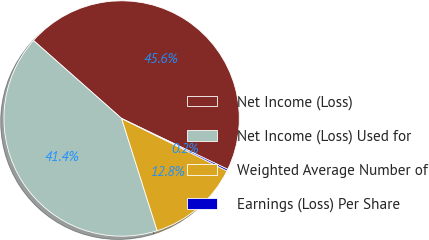<chart> <loc_0><loc_0><loc_500><loc_500><pie_chart><fcel>Net Income (Loss)<fcel>Net Income (Loss) Used for<fcel>Weighted Average Number of<fcel>Earnings (Loss) Per Share<nl><fcel>45.58%<fcel>41.41%<fcel>12.77%<fcel>0.24%<nl></chart> 